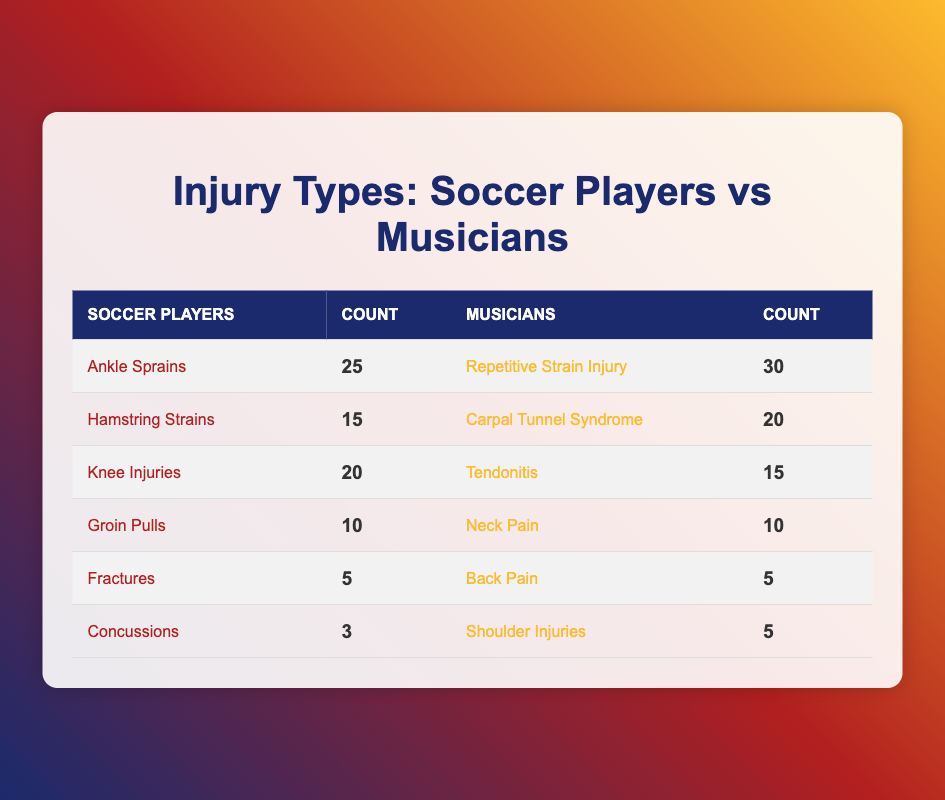What is the count of ankle sprains among soccer players? According to the table, the specific injury type "Ankle Sprains" under the "Soccer Players" category shows a count of 25.
Answer: 25 Which injury type has the highest count among musicians? When examining the "Musicians" column, "Repetitive Strain Injury" shows the highest count with 30.
Answer: Repetitive Strain Injury What is the total count of knee injuries among soccer players and tendonitis among musicians? To find this, we look at the "Knee Injuries" for soccer players, which is 20, and "Tendonitis" for musicians, which is 15. Adding these together gives us 20 + 15 = 35.
Answer: 35 Is the number of hamstring strains greater than the number of shoulder injuries among musicians? The table shows "Hamstring Strains" for soccer players is 15, while "Shoulder Injuries" for musicians is 5. Since 15 is greater than 5, the answer is yes.
Answer: Yes What is the difference in counts between groin pulls and neck pain? First, we find the count for "Groin Pulls" which is 10 for soccer players, and for "Neck Pain," it is 10 for musicians. The difference is calculated by subtracting: 10 - 10 = 0.
Answer: 0 What is the total number of injuries reported for soccer players? We sum all counts of injuries for soccer players: 25 + 15 + 20 + 10 + 5 + 3 = 78. Thus, the total number of injuries is 78.
Answer: 78 Are there more repetitive strain injuries among musicians than ankle sprains among soccer players? Repetitive Strain Injury has a count of 30 for musicians and Ankle Sprains has a count of 25 for soccer players. Since 30 is greater than 25, the answer is yes.
Answer: Yes What is the average count of injuries among soccer players? The total for soccer players is 78 (calculated previously) and there are 6 injury types. Therefore, the average is 78 / 6 = 13.
Answer: 13 